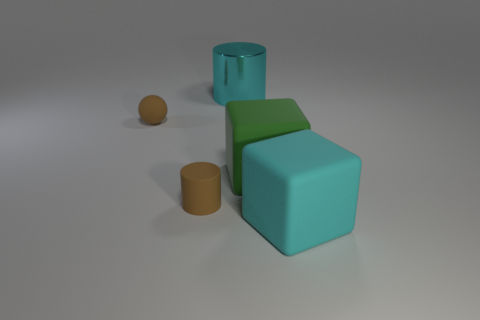Subtract all green cubes. Subtract all blue cylinders. How many cubes are left? 1 Add 2 tiny matte cylinders. How many objects exist? 7 Subtract all cylinders. How many objects are left? 3 Add 1 big cyan metal cylinders. How many big cyan metal cylinders are left? 2 Add 2 tiny brown cylinders. How many tiny brown cylinders exist? 3 Subtract 0 gray spheres. How many objects are left? 5 Subtract all large cyan things. Subtract all big metallic cylinders. How many objects are left? 2 